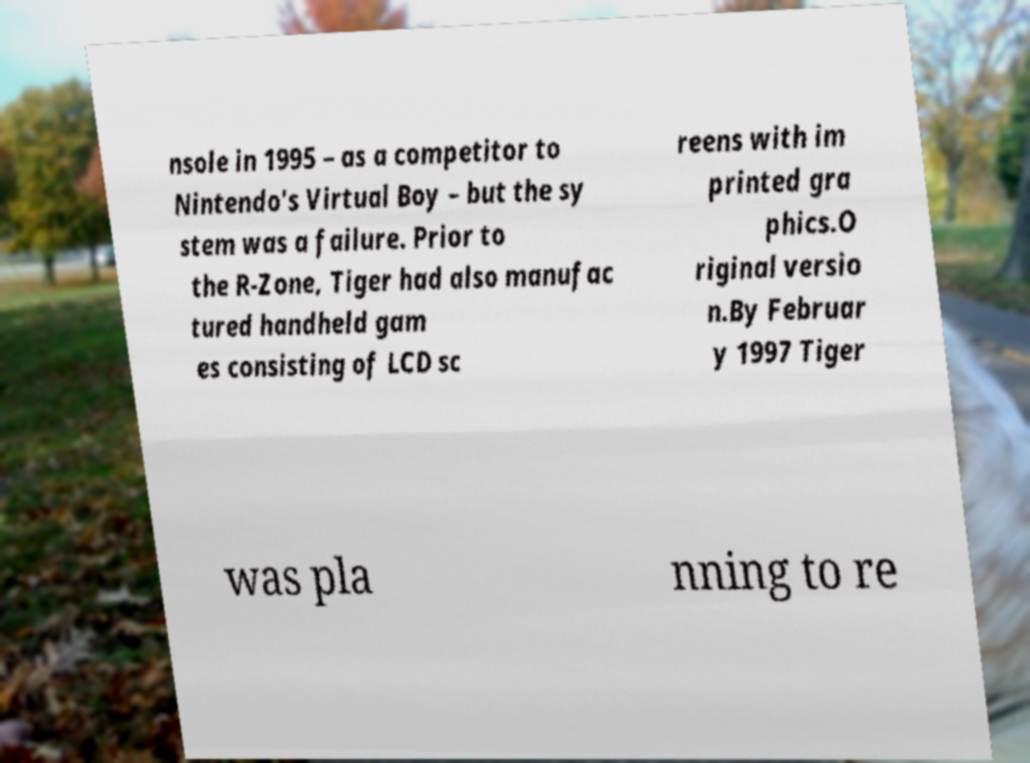There's text embedded in this image that I need extracted. Can you transcribe it verbatim? nsole in 1995 – as a competitor to Nintendo's Virtual Boy – but the sy stem was a failure. Prior to the R-Zone, Tiger had also manufac tured handheld gam es consisting of LCD sc reens with im printed gra phics.O riginal versio n.By Februar y 1997 Tiger was pla nning to re 